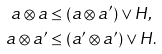Convert formula to latex. <formula><loc_0><loc_0><loc_500><loc_500>a \otimes a & \leq ( a \otimes a ^ { \prime } ) \vee H , \\ a \otimes a ^ { \prime } & \leq ( a ^ { \prime } \otimes a ^ { \prime } ) \vee H .</formula> 